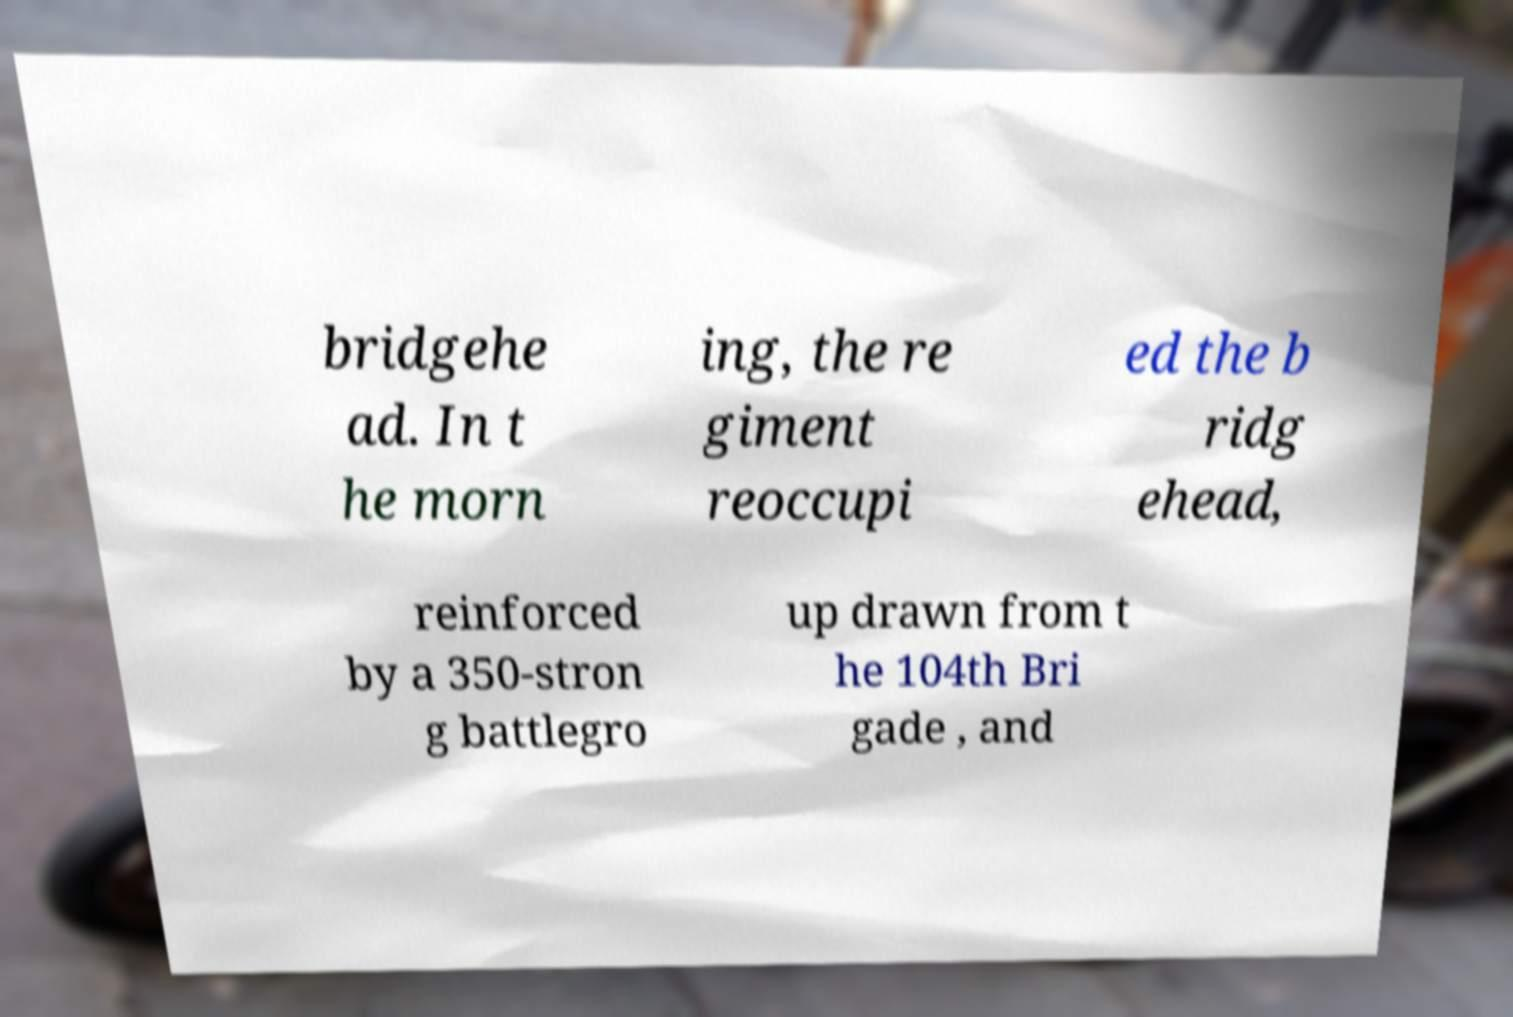Please identify and transcribe the text found in this image. bridgehe ad. In t he morn ing, the re giment reoccupi ed the b ridg ehead, reinforced by a 350-stron g battlegro up drawn from t he 104th Bri gade , and 